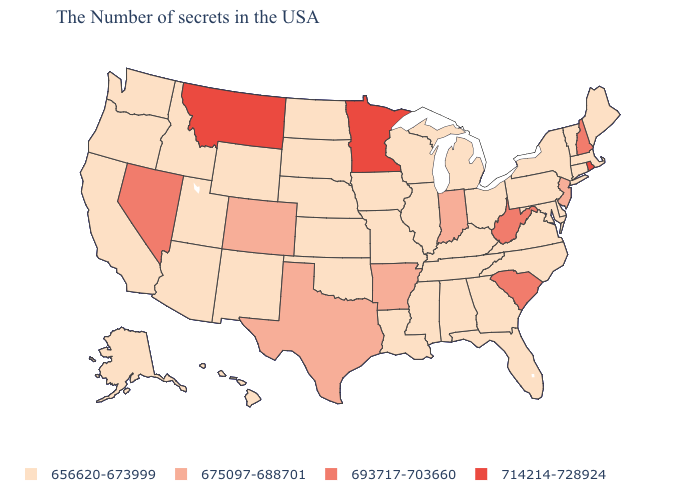Name the states that have a value in the range 656620-673999?
Be succinct. Maine, Massachusetts, Vermont, Connecticut, New York, Delaware, Maryland, Pennsylvania, Virginia, North Carolina, Ohio, Florida, Georgia, Michigan, Kentucky, Alabama, Tennessee, Wisconsin, Illinois, Mississippi, Louisiana, Missouri, Iowa, Kansas, Nebraska, Oklahoma, South Dakota, North Dakota, Wyoming, New Mexico, Utah, Arizona, Idaho, California, Washington, Oregon, Alaska, Hawaii. Which states have the lowest value in the USA?
Be succinct. Maine, Massachusetts, Vermont, Connecticut, New York, Delaware, Maryland, Pennsylvania, Virginia, North Carolina, Ohio, Florida, Georgia, Michigan, Kentucky, Alabama, Tennessee, Wisconsin, Illinois, Mississippi, Louisiana, Missouri, Iowa, Kansas, Nebraska, Oklahoma, South Dakota, North Dakota, Wyoming, New Mexico, Utah, Arizona, Idaho, California, Washington, Oregon, Alaska, Hawaii. Name the states that have a value in the range 656620-673999?
Keep it brief. Maine, Massachusetts, Vermont, Connecticut, New York, Delaware, Maryland, Pennsylvania, Virginia, North Carolina, Ohio, Florida, Georgia, Michigan, Kentucky, Alabama, Tennessee, Wisconsin, Illinois, Mississippi, Louisiana, Missouri, Iowa, Kansas, Nebraska, Oklahoma, South Dakota, North Dakota, Wyoming, New Mexico, Utah, Arizona, Idaho, California, Washington, Oregon, Alaska, Hawaii. How many symbols are there in the legend?
Quick response, please. 4. Which states hav the highest value in the Northeast?
Concise answer only. Rhode Island. Does the map have missing data?
Keep it brief. No. Name the states that have a value in the range 675097-688701?
Be succinct. New Jersey, Indiana, Arkansas, Texas, Colorado. What is the value of Oregon?
Short answer required. 656620-673999. How many symbols are there in the legend?
Short answer required. 4. What is the value of Rhode Island?
Write a very short answer. 714214-728924. What is the value of California?
Give a very brief answer. 656620-673999. What is the highest value in the USA?
Be succinct. 714214-728924. What is the highest value in the USA?
Answer briefly. 714214-728924. What is the value of Wisconsin?
Keep it brief. 656620-673999. What is the highest value in the USA?
Answer briefly. 714214-728924. 